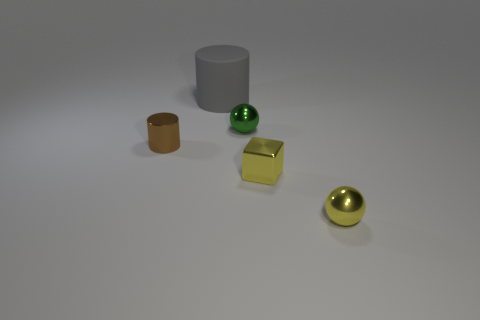The cylinder behind the tiny brown cylinder is what color?
Keep it short and to the point. Gray. Is the number of tiny shiny cubes in front of the small yellow block greater than the number of matte things?
Provide a short and direct response. No. Is the shape of the small metallic object behind the small brown thing the same as  the big object?
Offer a very short reply. No. What number of purple things are either small shiny objects or tiny shiny cubes?
Your response must be concise. 0. Is the number of tiny cylinders greater than the number of tiny blue objects?
Provide a short and direct response. Yes. The metal cylinder that is the same size as the metal block is what color?
Keep it short and to the point. Brown. What number of spheres are brown metallic things or tiny objects?
Ensure brevity in your answer.  2. Do the big gray rubber object and the tiny metallic object behind the tiny brown shiny cylinder have the same shape?
Give a very brief answer. No. What number of green metal balls have the same size as the green metallic thing?
Your answer should be very brief. 0. Is the shape of the shiny object behind the small brown object the same as the metallic thing that is on the left side of the small green thing?
Give a very brief answer. No. 